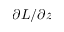<formula> <loc_0><loc_0><loc_500><loc_500>\partial L / \partial z</formula> 